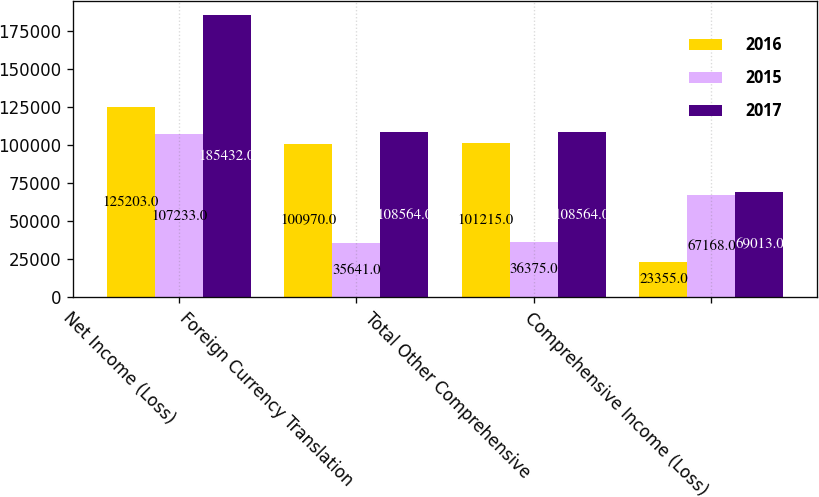Convert chart to OTSL. <chart><loc_0><loc_0><loc_500><loc_500><stacked_bar_chart><ecel><fcel>Net Income (Loss)<fcel>Foreign Currency Translation<fcel>Total Other Comprehensive<fcel>Comprehensive Income (Loss)<nl><fcel>2016<fcel>125203<fcel>100970<fcel>101215<fcel>23355<nl><fcel>2015<fcel>107233<fcel>35641<fcel>36375<fcel>67168<nl><fcel>2017<fcel>185432<fcel>108564<fcel>108564<fcel>69013<nl></chart> 